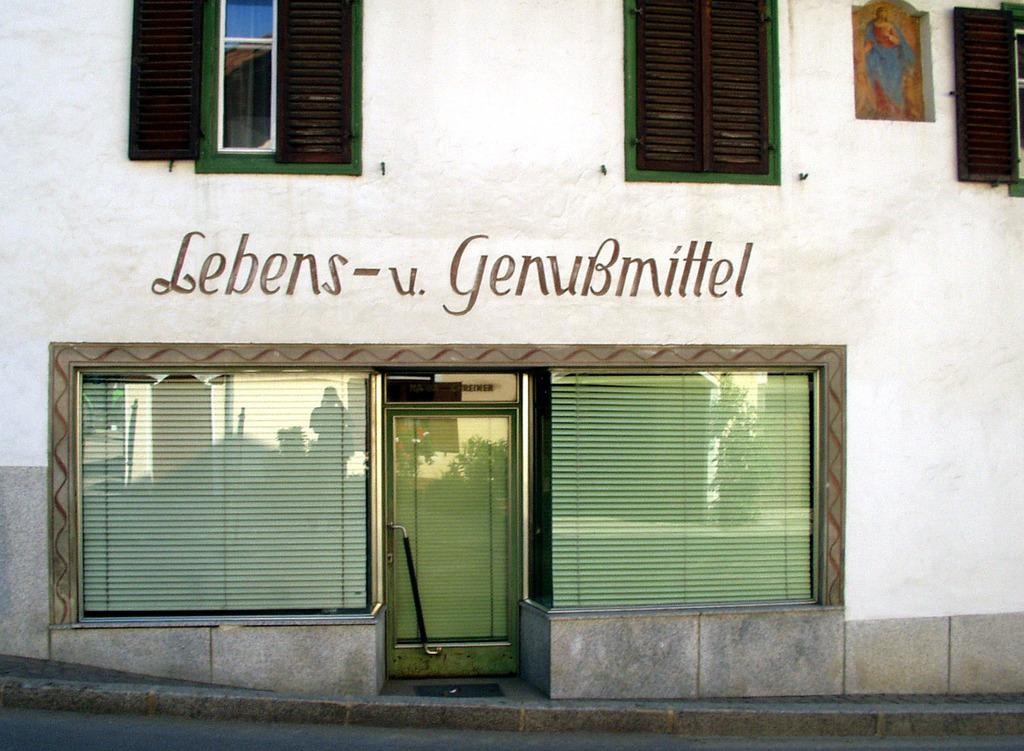What type of structure is present in the image? There is a building in the image. What features can be observed on the building? The building has windows and a door. Is there any text visible in the image? Yes, there is some text visible in the image. How much grip does the building have on the ground in the image? The building's grip on the ground is not visible or measurable in the image. 